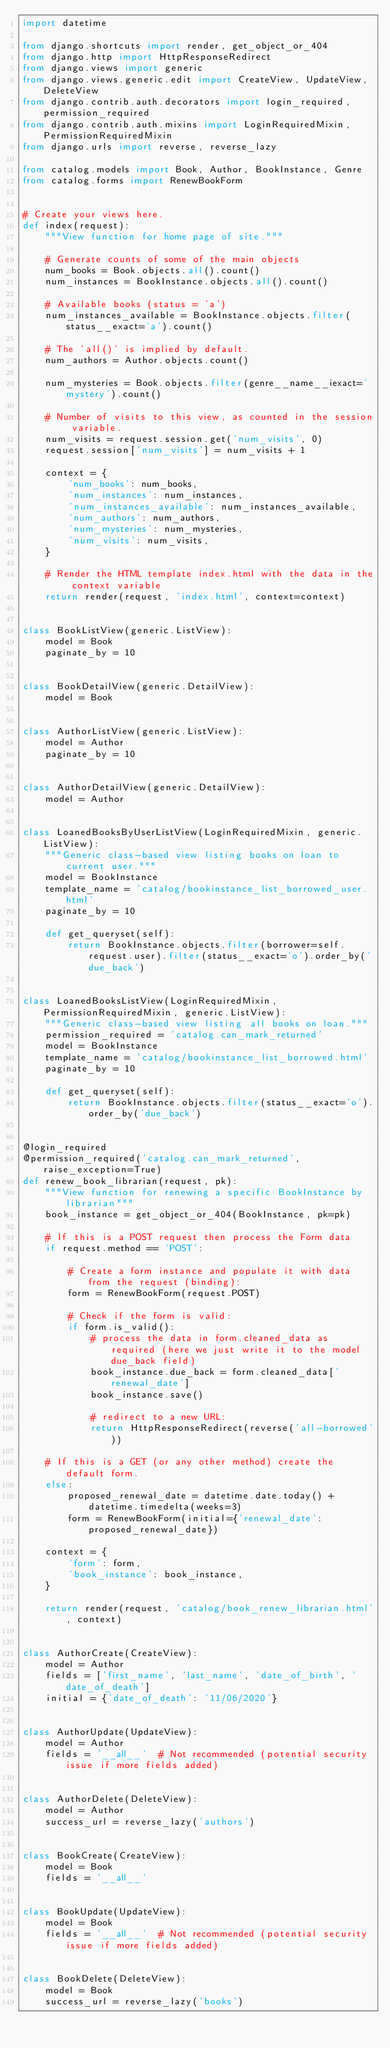Convert code to text. <code><loc_0><loc_0><loc_500><loc_500><_Python_>import datetime

from django.shortcuts import render, get_object_or_404
from django.http import HttpResponseRedirect
from django.views import generic
from django.views.generic.edit import CreateView, UpdateView, DeleteView
from django.contrib.auth.decorators import login_required, permission_required
from django.contrib.auth.mixins import LoginRequiredMixin, PermissionRequiredMixin
from django.urls import reverse, reverse_lazy

from catalog.models import Book, Author, BookInstance, Genre
from catalog.forms import RenewBookForm


# Create your views here.
def index(request):
    """View function for home page of site."""

    # Generate counts of some of the main objects
    num_books = Book.objects.all().count()
    num_instances = BookInstance.objects.all().count()

    # Available books (status = 'a')
    num_instances_available = BookInstance.objects.filter(status__exact='a').count()

    # The 'all()' is implied by default.
    num_authors = Author.objects.count()

    num_mysteries = Book.objects.filter(genre__name__iexact='mystery').count()

    # Number of visits to this view, as counted in the session variable.
    num_visits = request.session.get('num_visits', 0)
    request.session['num_visits'] = num_visits + 1

    context = {
        'num_books': num_books,
        'num_instances': num_instances,
        'num_instances_available': num_instances_available,
        'num_authors': num_authors,
        'num_mysteries': num_mysteries,
        'num_visits': num_visits,
    }

    # Render the HTML template index.html with the data in the context variable
    return render(request, 'index.html', context=context)


class BookListView(generic.ListView):
    model = Book
    paginate_by = 10


class BookDetailView(generic.DetailView):
    model = Book


class AuthorListView(generic.ListView):
    model = Author
    paginate_by = 10


class AuthorDetailView(generic.DetailView):
    model = Author


class LoanedBooksByUserListView(LoginRequiredMixin, generic.ListView):
    """Generic class-based view listing books on loan to current user."""
    model = BookInstance
    template_name = 'catalog/bookinstance_list_borrowed_user.html'
    paginate_by = 10

    def get_queryset(self):
        return BookInstance.objects.filter(borrower=self.request.user).filter(status__exact='o').order_by('due_back')


class LoanedBooksListView(LoginRequiredMixin, PermissionRequiredMixin, generic.ListView):
    """Generic class-based view listing all books on loan."""
    permission_required = 'catalog.can_mark_returned'
    model = BookInstance
    template_name = 'catalog/bookinstance_list_borrowed.html'
    paginate_by = 10

    def get_queryset(self):
        return BookInstance.objects.filter(status__exact='o').order_by('due_back')


@login_required
@permission_required('catalog.can_mark_returned', raise_exception=True)
def renew_book_librarian(request, pk):
    """View function for renewing a specific BookInstance by librarian"""
    book_instance = get_object_or_404(BookInstance, pk=pk)

    # If this is a POST request then process the Form data
    if request.method == 'POST':

        # Create a form instance and populate it with data from the request (binding):
        form = RenewBookForm(request.POST)

        # Check if the form is valid:
        if form.is_valid():
            # process the data in form.cleaned_data as required (here we just write it to the model due_back field)
            book_instance.due_back = form.cleaned_data['renewal_date']
            book_instance.save()

            # redirect to a new URL:
            return HttpResponseRedirect(reverse('all-borrowed'))

    # If this is a GET (or any other method) create the default form.
    else:
        proposed_renewal_date = datetime.date.today() + datetime.timedelta(weeks=3)
        form = RenewBookForm(initial={'renewal_date': proposed_renewal_date})

    context = {
        'form': form,
        'book_instance': book_instance,
    }

    return render(request, 'catalog/book_renew_librarian.html', context)


class AuthorCreate(CreateView):
    model = Author
    fields = ['first_name', 'last_name', 'date_of_birth', 'date_of_death']
    initial = {'date_of_death': '11/06/2020'}


class AuthorUpdate(UpdateView):
    model = Author
    fields = '__all__'  # Not recommended (potential security issue if more fields added)


class AuthorDelete(DeleteView):
    model = Author
    success_url = reverse_lazy('authors')


class BookCreate(CreateView):
    model = Book
    fields = '__all__'


class BookUpdate(UpdateView):
    model = Book
    fields = '__all__'  # Not recommended (potential security issue if more fields added)


class BookDelete(DeleteView):
    model = Book
    success_url = reverse_lazy('books')</code> 